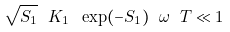Convert formula to latex. <formula><loc_0><loc_0><loc_500><loc_500>\sqrt { S _ { 1 } } \ K _ { 1 } \ \exp ( - S _ { 1 } ) \ \omega \ T \ll 1</formula> 